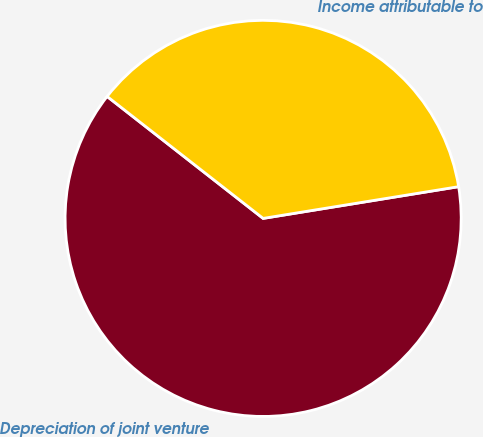Convert chart to OTSL. <chart><loc_0><loc_0><loc_500><loc_500><pie_chart><fcel>Depreciation of joint venture<fcel>Income attributable to<nl><fcel>63.12%<fcel>36.88%<nl></chart> 